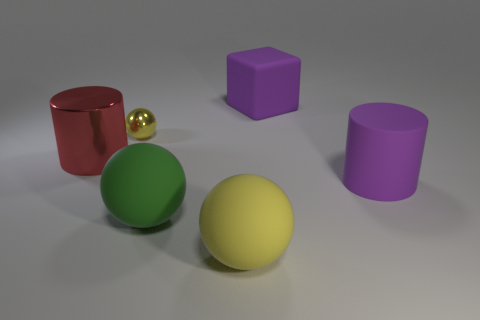The tiny metallic sphere has what color?
Keep it short and to the point. Yellow. Is the metallic cylinder the same size as the green matte sphere?
Offer a terse response. Yes. What number of objects are either small red matte cubes or yellow metallic objects?
Offer a terse response. 1. Are there the same number of yellow balls that are behind the matte cube and purple rubber cubes?
Make the answer very short. No. There is a metallic thing that is behind the large cylinder behind the large purple cylinder; are there any yellow metallic balls that are on the left side of it?
Your answer should be compact. No. What color is the big cylinder that is the same material as the big cube?
Provide a succinct answer. Purple. Is the color of the big object left of the big green ball the same as the block?
Make the answer very short. No. What number of spheres are either brown shiny objects or tiny shiny things?
Your answer should be compact. 1. How big is the sphere behind the cylinder in front of the large red shiny cylinder behind the big yellow thing?
Provide a succinct answer. Small. There is a purple rubber object that is the same size as the rubber cube; what is its shape?
Your answer should be compact. Cylinder. 